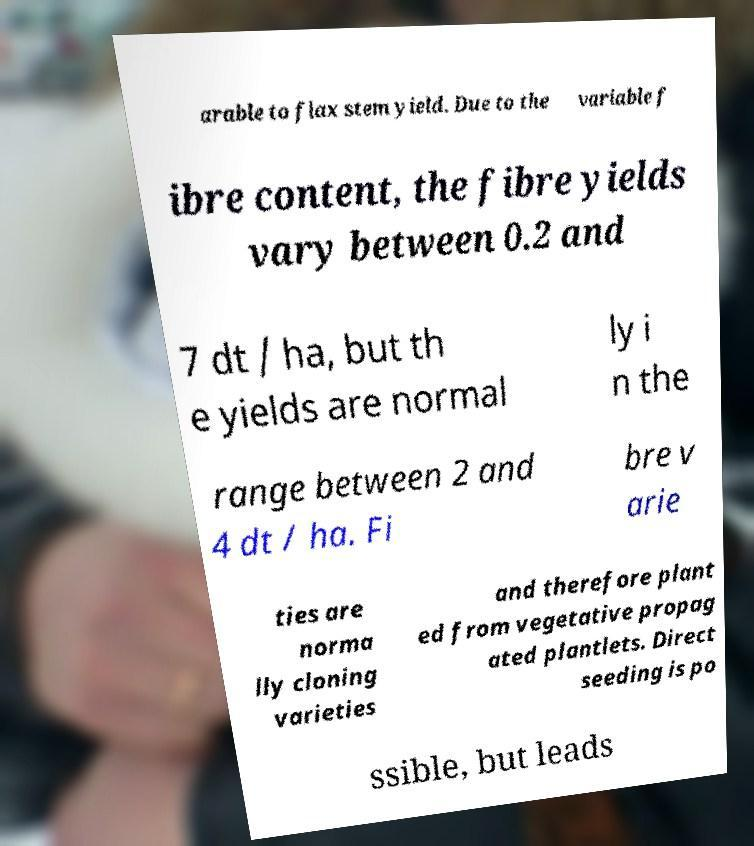Please read and relay the text visible in this image. What does it say? arable to flax stem yield. Due to the variable f ibre content, the fibre yields vary between 0.2 and 7 dt / ha, but th e yields are normal ly i n the range between 2 and 4 dt / ha. Fi bre v arie ties are norma lly cloning varieties and therefore plant ed from vegetative propag ated plantlets. Direct seeding is po ssible, but leads 